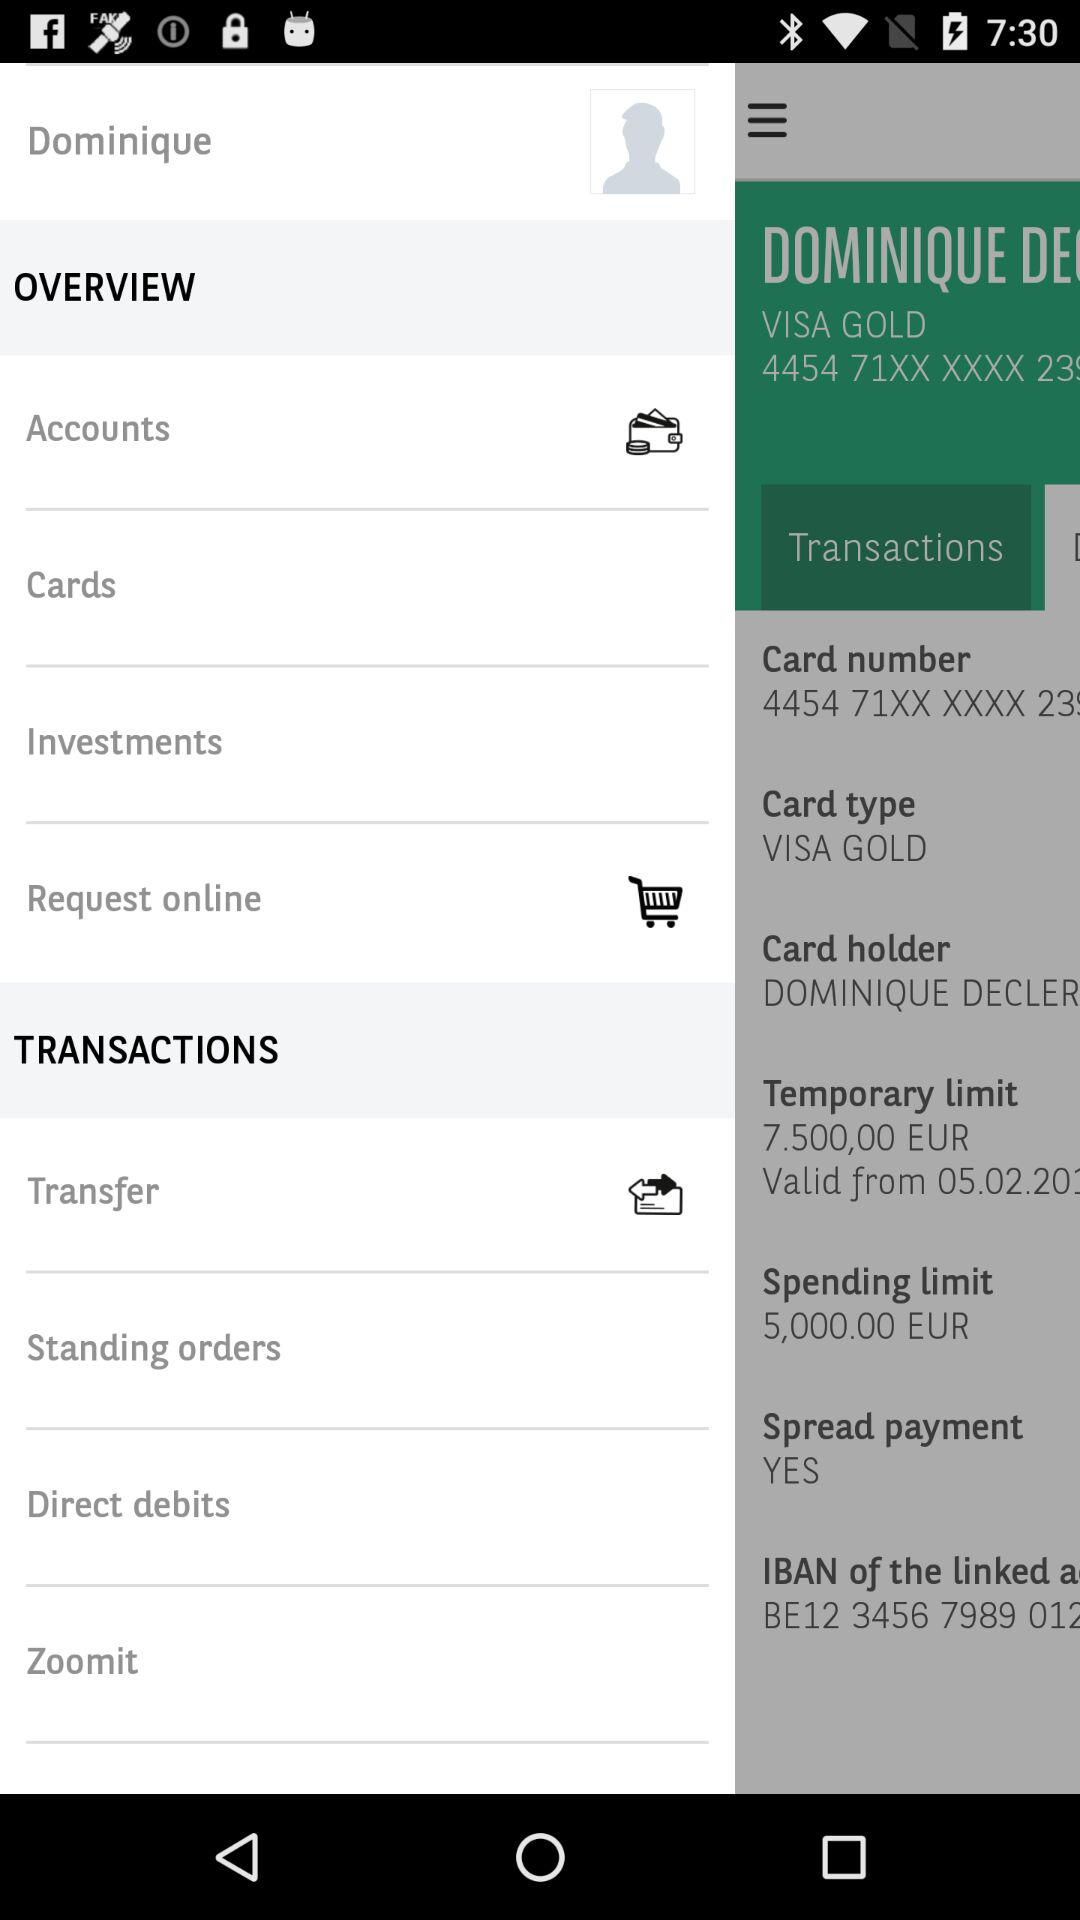What is the spending limit? The spending limit is 5,000 EUR. 